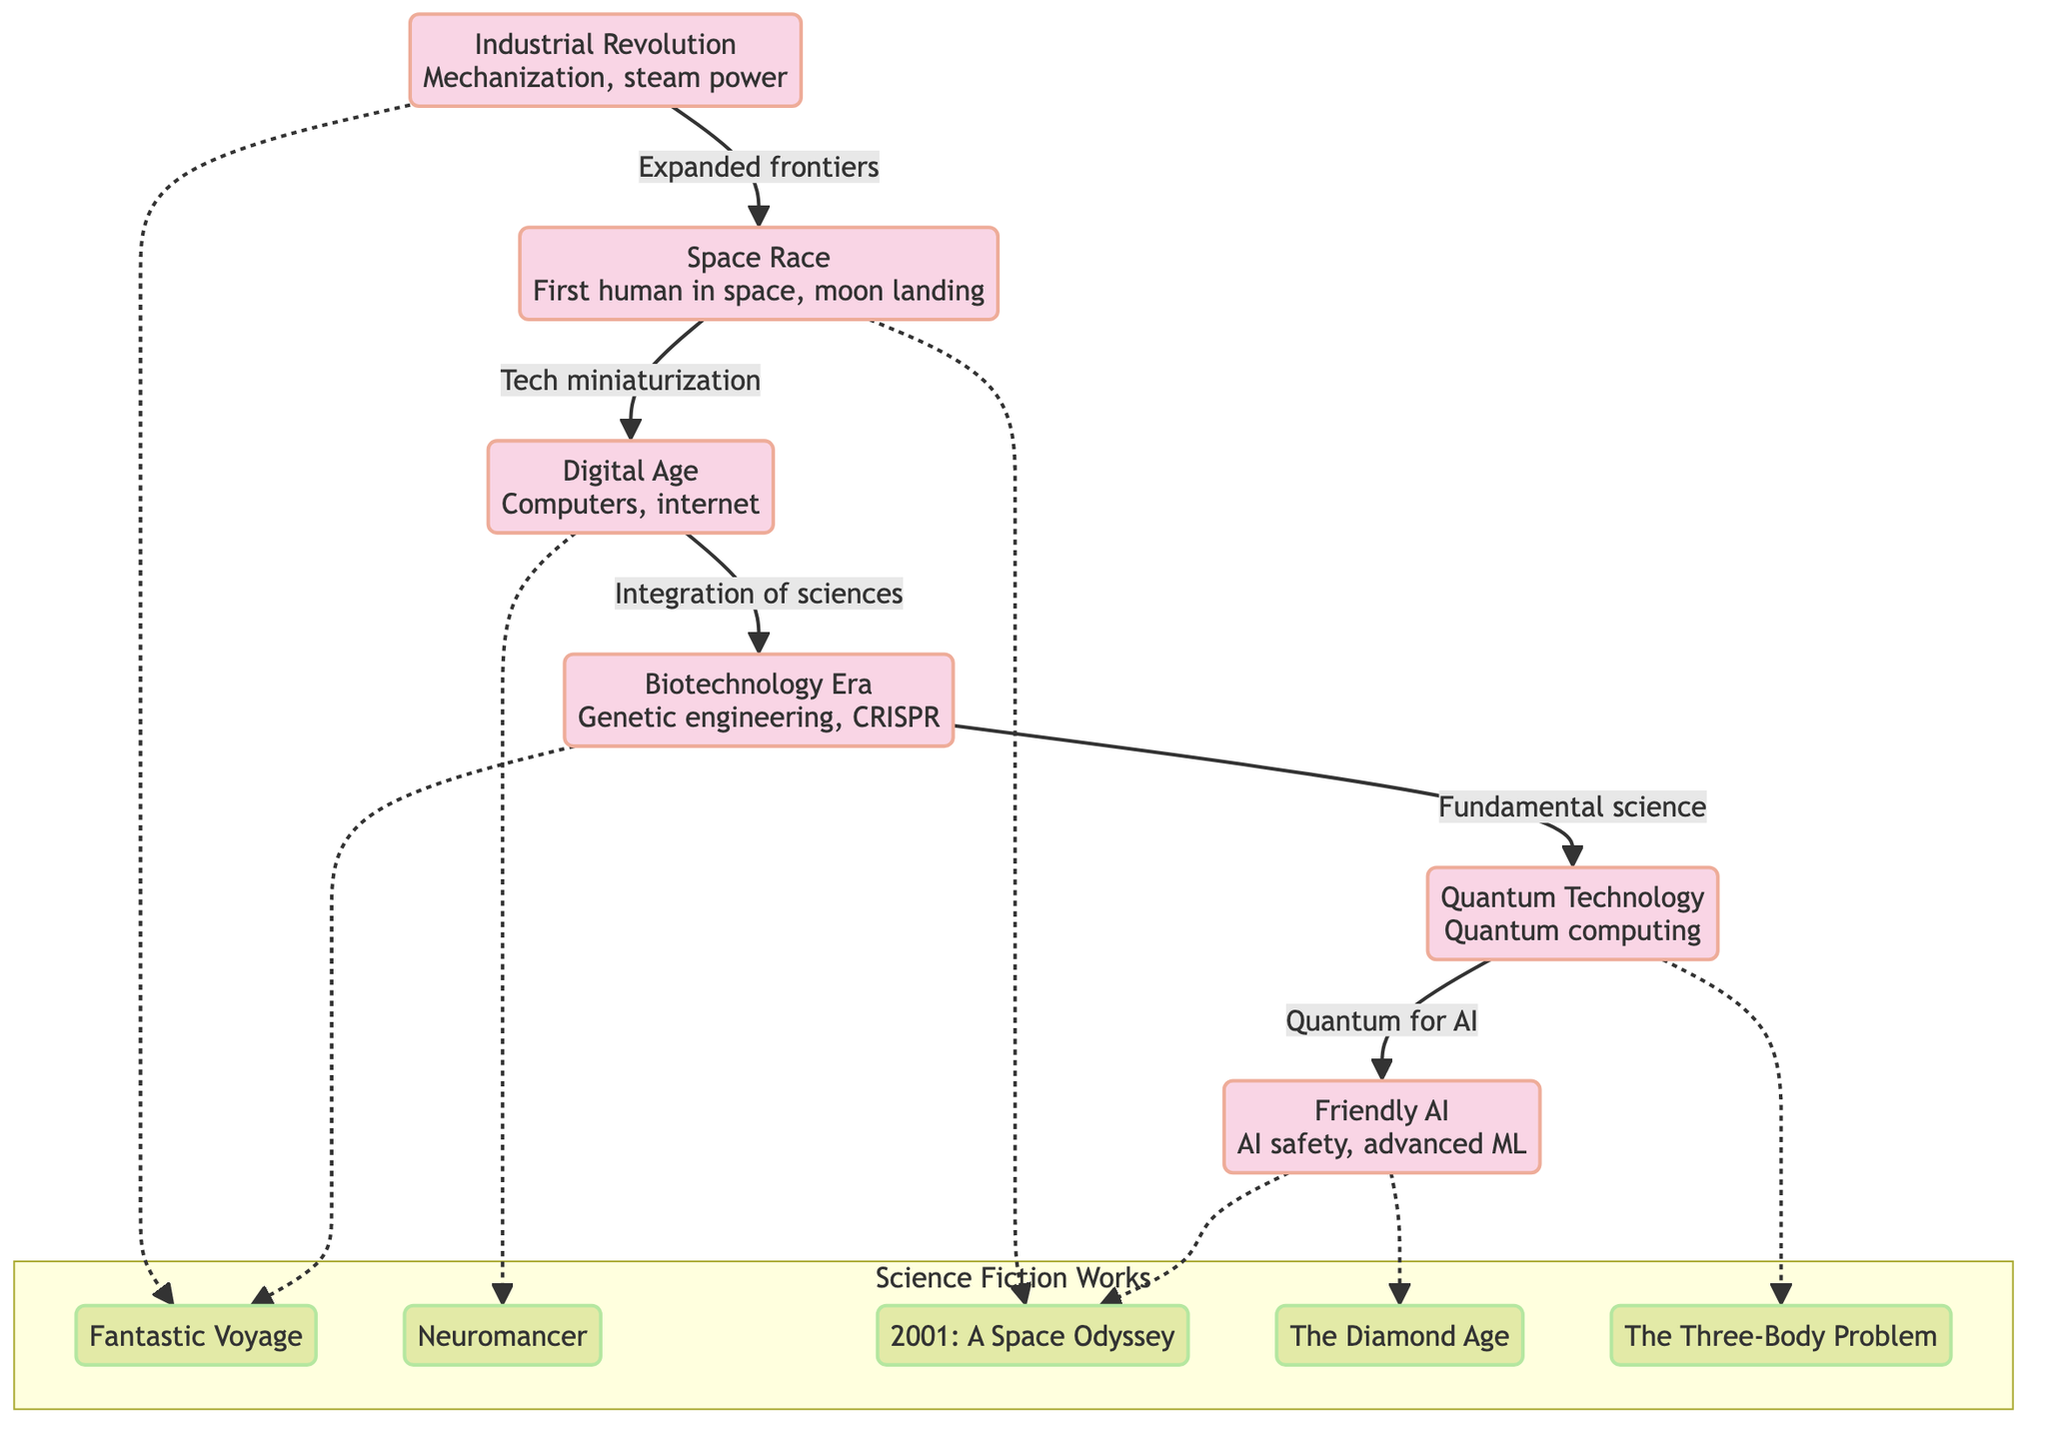What technological advancement directly follows the Industrial Revolution? The Industrial Revolution is followed directly by the Space Race in the flowchart, as indicated by the arrow showing the progression of technological advancements.
Answer: Space Race How many science fiction works are represented in the diagram? The diagram contains five science fiction works listed under the "Science Fiction Works" subgraph. These include Fantastic Voyage, Neuromancer, 2001: A Space Odyssey, The Diamond Age, and The Three-Body Problem.
Answer: 5 Which technological advancement leads to Quantum Technology? The sequence in the diagram shows that Biotechnology Era directly leads to Quantum Technology, as seen from the arrow connecting the two nodes.
Answer: Biotechnology Era What is a key theme connecting the Digital Age to Neuromancer? The arrow from Digital Age to Neuromancer indicates a relationship named "Tech miniaturization", which implies that advancements in the Digital Age influenced the themes present in Neuromancer.
Answer: Tech miniaturization Which science fiction work is associated with Friendly AI? According to the diagram, Friendly AI has arrows pointing towards two science fiction works: 2001: A Space Odyssey and The Diamond Age, indicating its thematic relevance to both.
Answer: 2001: A Space Odyssey, The Diamond Age What type of relationship exists between Biotechnology Era and Fantastic Voyage? The relationship is represented by a dashed line in the diagram, which symbolizes a less direct or conceptual connection, contrasting with the solid lines of direct advancements.
Answer: Conceptual connection Which advanced technology is directly linked to AI? The diagram indicates, through the progression from Quantum Technology, that Quantum Technology leads to Friendly AI, connecting these advanced technological concepts.
Answer: Quantum Technology Name the first node in the technological advancements sequence. The first node in the sequence of technological advancements listed in the diagram is the Industrial Revolution, which starts the flow of advancements leading to further technologies.
Answer: Industrial Revolution What is the final technological advancement in the diagram? Following the progression in the flowchart, the final technological advancement listed is Friendly AI, which comes after Quantum Technology.
Answer: Friendly AI 